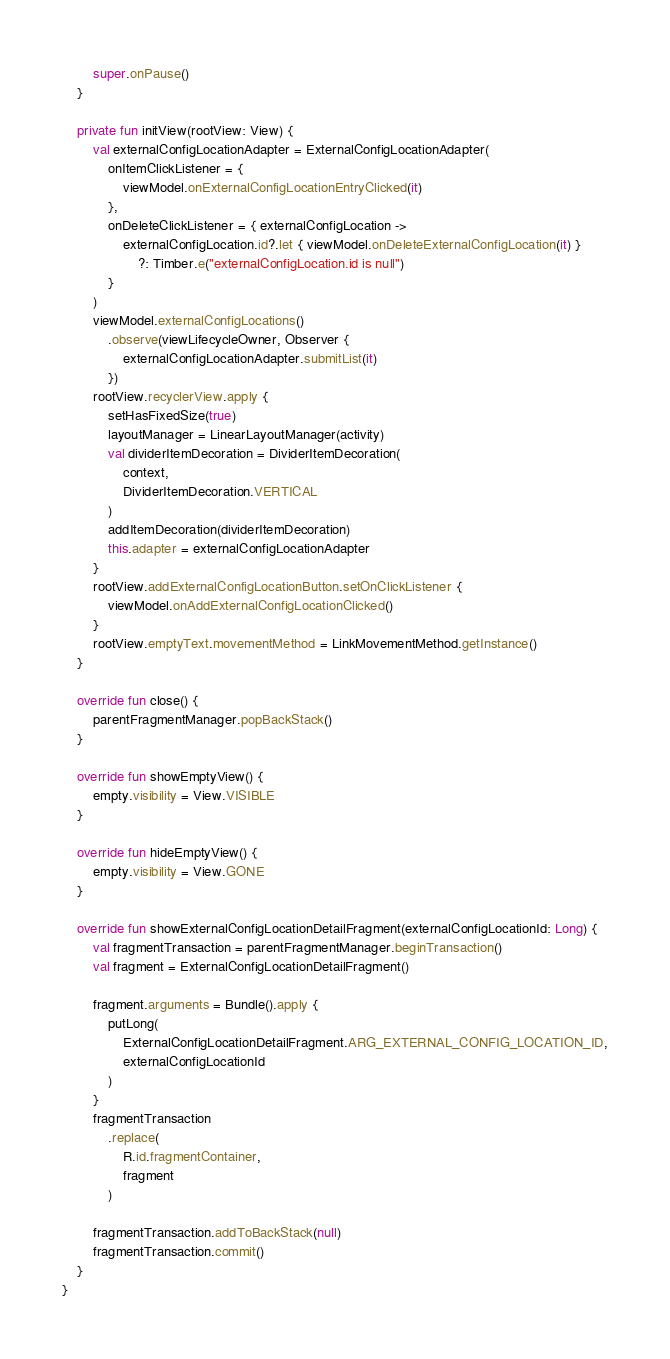Convert code to text. <code><loc_0><loc_0><loc_500><loc_500><_Kotlin_>        super.onPause()
    }

    private fun initView(rootView: View) {
        val externalConfigLocationAdapter = ExternalConfigLocationAdapter(
            onItemClickListener = {
                viewModel.onExternalConfigLocationEntryClicked(it)
            },
            onDeleteClickListener = { externalConfigLocation ->
                externalConfigLocation.id?.let { viewModel.onDeleteExternalConfigLocation(it) }
                    ?: Timber.e("externalConfigLocation.id is null")
            }
        )
        viewModel.externalConfigLocations()
            .observe(viewLifecycleOwner, Observer {
                externalConfigLocationAdapter.submitList(it)
            })
        rootView.recyclerView.apply {
            setHasFixedSize(true)
            layoutManager = LinearLayoutManager(activity)
            val dividerItemDecoration = DividerItemDecoration(
                context,
                DividerItemDecoration.VERTICAL
            )
            addItemDecoration(dividerItemDecoration)
            this.adapter = externalConfigLocationAdapter
        }
        rootView.addExternalConfigLocationButton.setOnClickListener {
            viewModel.onAddExternalConfigLocationClicked()
        }
        rootView.emptyText.movementMethod = LinkMovementMethod.getInstance()
    }

    override fun close() {
        parentFragmentManager.popBackStack()
    }

    override fun showEmptyView() {
        empty.visibility = View.VISIBLE
    }

    override fun hideEmptyView() {
        empty.visibility = View.GONE
    }

    override fun showExternalConfigLocationDetailFragment(externalConfigLocationId: Long) {
        val fragmentTransaction = parentFragmentManager.beginTransaction()
        val fragment = ExternalConfigLocationDetailFragment()

        fragment.arguments = Bundle().apply {
            putLong(
                ExternalConfigLocationDetailFragment.ARG_EXTERNAL_CONFIG_LOCATION_ID,
                externalConfigLocationId
            )
        }
        fragmentTransaction
            .replace(
                R.id.fragmentContainer,
                fragment
            )

        fragmentTransaction.addToBackStack(null)
        fragmentTransaction.commit()
    }
}
</code> 